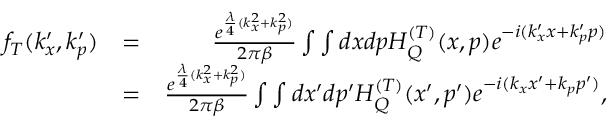<formula> <loc_0><loc_0><loc_500><loc_500>\begin{array} { r l r } { f _ { T } ( k _ { x } ^ { \prime } , k _ { p } ^ { \prime } ) } & { = } & { \frac { e ^ { \frac { \lambda } { 4 } ( k _ { x } ^ { 2 } + k _ { p } ^ { 2 } ) } } { 2 \pi \beta } \int \int d x d p H _ { Q } ^ { ( T ) } ( x , p ) e ^ { - i ( k _ { x } ^ { \prime } x + k _ { p } ^ { \prime } p ) } } \\ & { = } & { \frac { e ^ { \frac { \lambda } { 4 } ( k _ { x } ^ { 2 } + k _ { p } ^ { 2 } ) } } { 2 \pi \beta } \int \int d x ^ { \prime } d p ^ { \prime } H _ { Q } ^ { ( T ) } ( x ^ { \prime } , p ^ { \prime } ) e ^ { - i ( k _ { x } x ^ { \prime } + k _ { p } p ^ { \prime } ) } , } \end{array}</formula> 